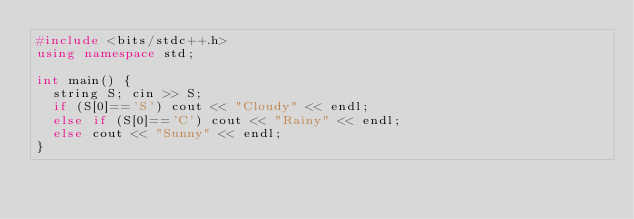<code> <loc_0><loc_0><loc_500><loc_500><_C++_>#include <bits/stdc++.h>
using namespace std;

int main() {
  string S; cin >> S;
  if (S[0]=='S') cout << "Cloudy" << endl;
  else if (S[0]=='C') cout << "Rainy" << endl;
  else cout << "Sunny" << endl;
}</code> 